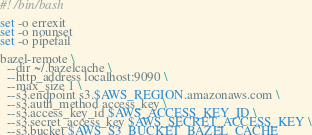Convert code to text. <code><loc_0><loc_0><loc_500><loc_500><_Bash_>#! /bin/bash

set -o errexit
set -o nounset
set -o pipefail

bazel-remote \
  --dir ~/.bazelcache \
  --http_address localhost:9090 \
  --max_size 1 \
  --s3.endpoint s3.$AWS_REGION.amazonaws.com \
  --s3.auth_method access_key \
  --s3.access_key_id $AWS_ACCESS_KEY_ID \
  --s3.secret_access_key $AWS_SECRET_ACCESS_KEY \
  --s3.bucket $AWS_S3_BUCKET_BAZEL_CACHE
</code> 